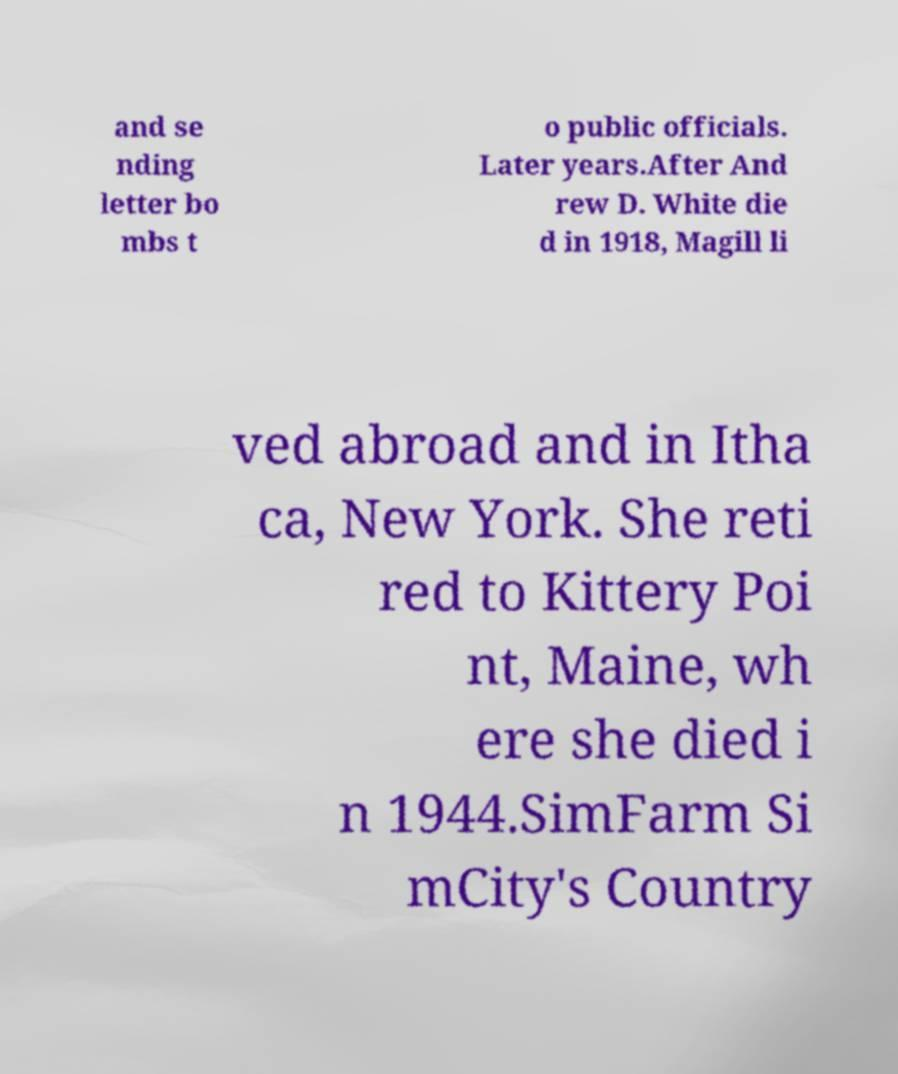There's text embedded in this image that I need extracted. Can you transcribe it verbatim? and se nding letter bo mbs t o public officials. Later years.After And rew D. White die d in 1918, Magill li ved abroad and in Itha ca, New York. She reti red to Kittery Poi nt, Maine, wh ere she died i n 1944.SimFarm Si mCity's Country 